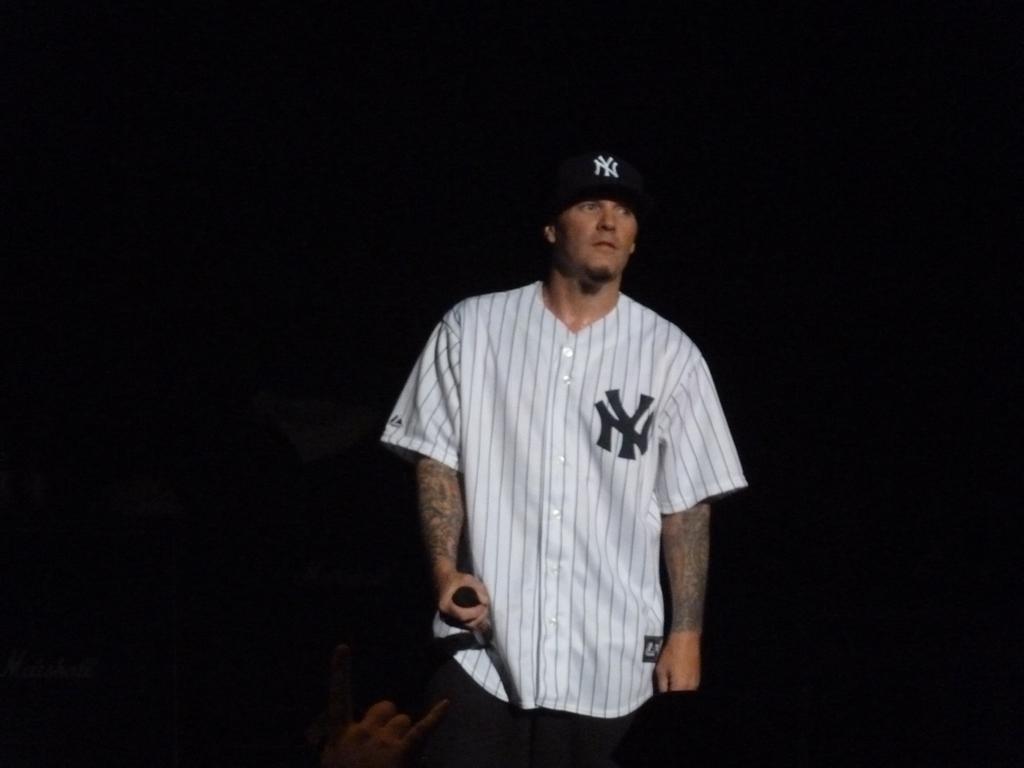What baseball team is this person representing?
Give a very brief answer. New york yankees. 